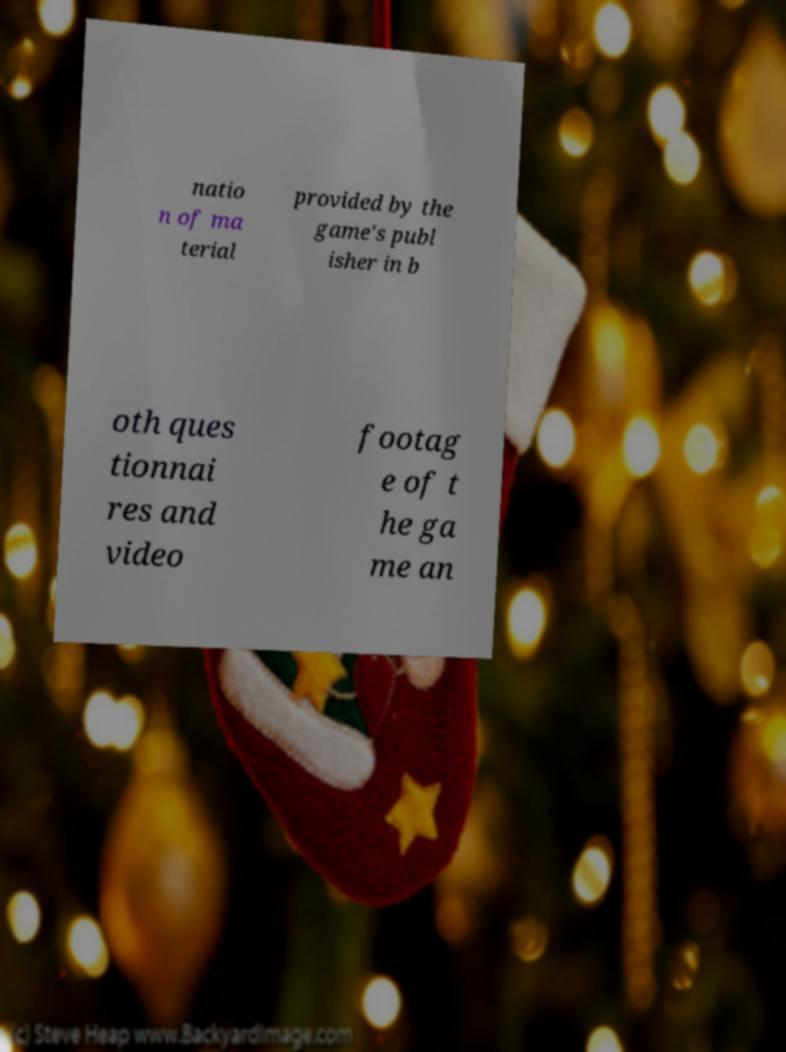Can you read and provide the text displayed in the image?This photo seems to have some interesting text. Can you extract and type it out for me? natio n of ma terial provided by the game's publ isher in b oth ques tionnai res and video footag e of t he ga me an 